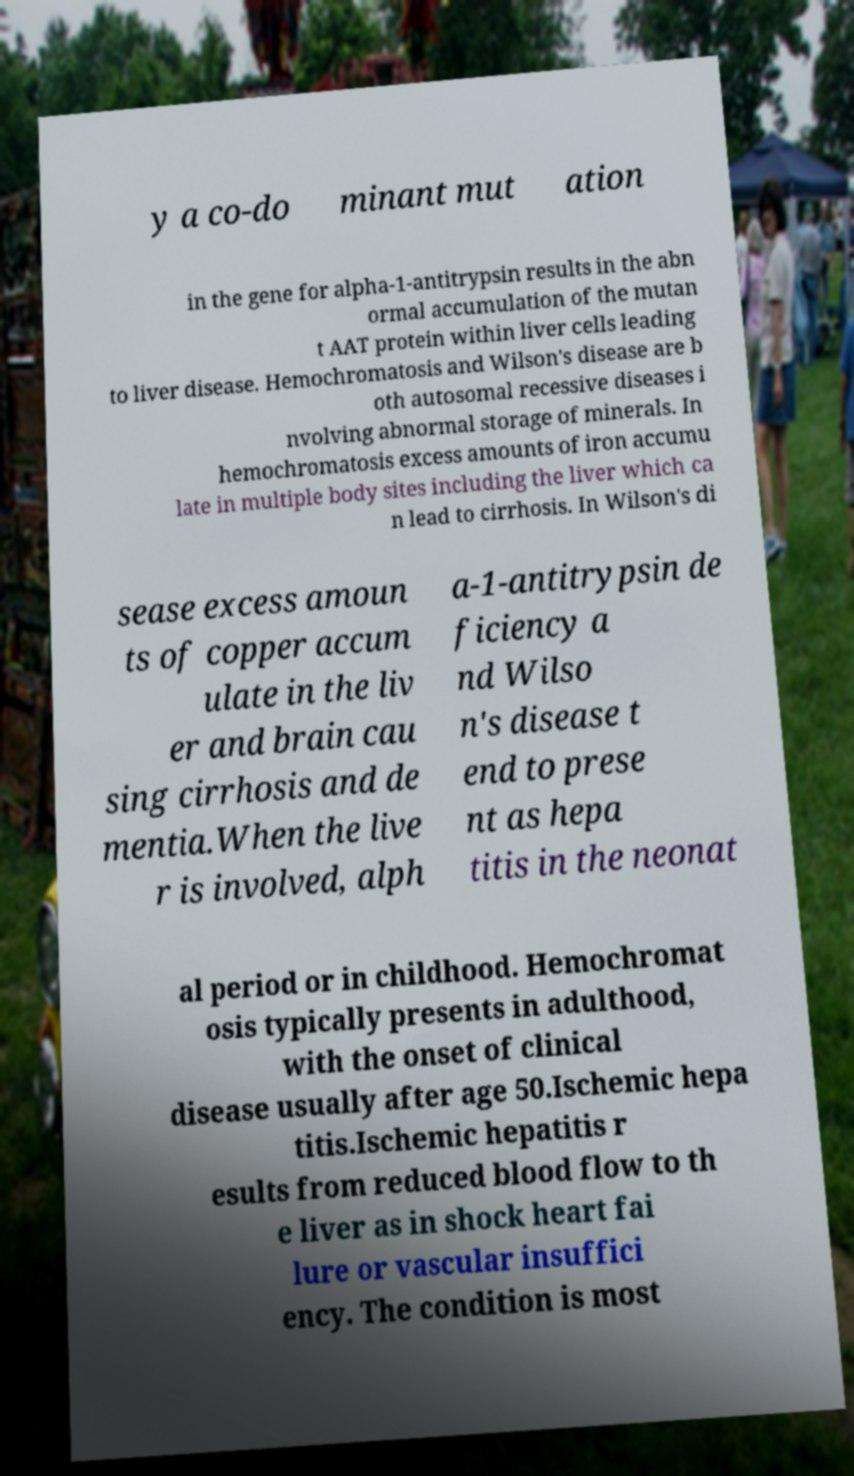Can you read and provide the text displayed in the image?This photo seems to have some interesting text. Can you extract and type it out for me? y a co-do minant mut ation in the gene for alpha-1-antitrypsin results in the abn ormal accumulation of the mutan t AAT protein within liver cells leading to liver disease. Hemochromatosis and Wilson's disease are b oth autosomal recessive diseases i nvolving abnormal storage of minerals. In hemochromatosis excess amounts of iron accumu late in multiple body sites including the liver which ca n lead to cirrhosis. In Wilson's di sease excess amoun ts of copper accum ulate in the liv er and brain cau sing cirrhosis and de mentia.When the live r is involved, alph a-1-antitrypsin de ficiency a nd Wilso n's disease t end to prese nt as hepa titis in the neonat al period or in childhood. Hemochromat osis typically presents in adulthood, with the onset of clinical disease usually after age 50.Ischemic hepa titis.Ischemic hepatitis r esults from reduced blood flow to th e liver as in shock heart fai lure or vascular insuffici ency. The condition is most 